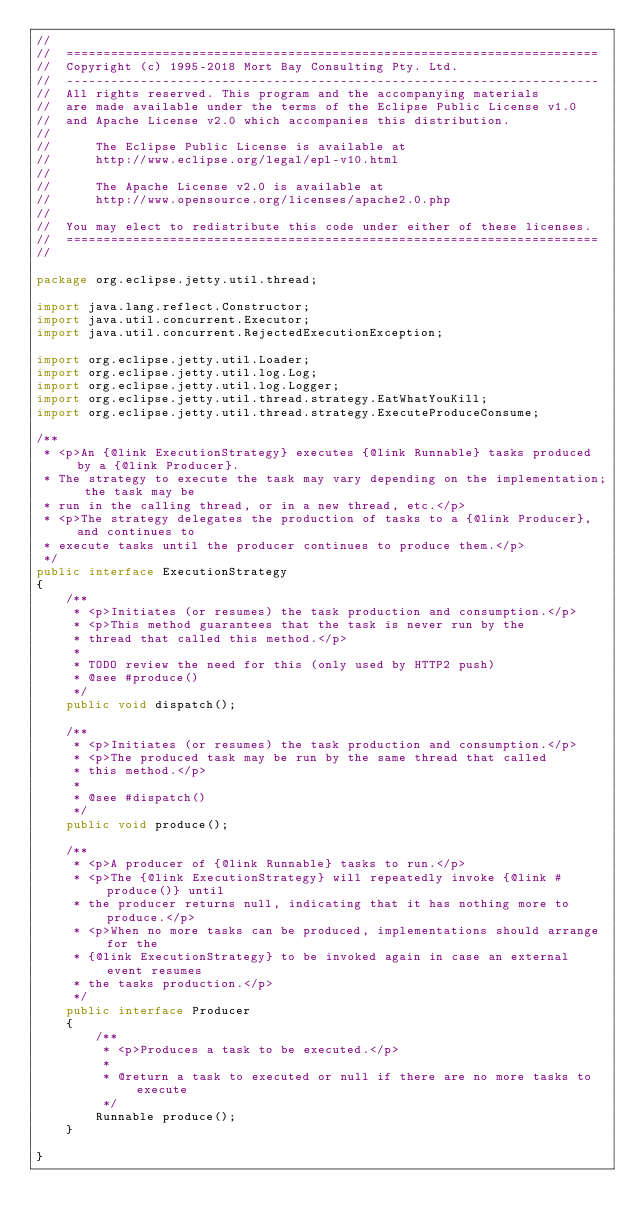<code> <loc_0><loc_0><loc_500><loc_500><_Java_>//
//  ========================================================================
//  Copyright (c) 1995-2018 Mort Bay Consulting Pty. Ltd.
//  ------------------------------------------------------------------------
//  All rights reserved. This program and the accompanying materials
//  are made available under the terms of the Eclipse Public License v1.0
//  and Apache License v2.0 which accompanies this distribution.
//
//      The Eclipse Public License is available at
//      http://www.eclipse.org/legal/epl-v10.html
//
//      The Apache License v2.0 is available at
//      http://www.opensource.org/licenses/apache2.0.php
//
//  You may elect to redistribute this code under either of these licenses.
//  ========================================================================
//

package org.eclipse.jetty.util.thread;

import java.lang.reflect.Constructor;
import java.util.concurrent.Executor;
import java.util.concurrent.RejectedExecutionException;

import org.eclipse.jetty.util.Loader;
import org.eclipse.jetty.util.log.Log;
import org.eclipse.jetty.util.log.Logger;
import org.eclipse.jetty.util.thread.strategy.EatWhatYouKill;
import org.eclipse.jetty.util.thread.strategy.ExecuteProduceConsume;

/**
 * <p>An {@link ExecutionStrategy} executes {@link Runnable} tasks produced by a {@link Producer}.
 * The strategy to execute the task may vary depending on the implementation; the task may be
 * run in the calling thread, or in a new thread, etc.</p>
 * <p>The strategy delegates the production of tasks to a {@link Producer}, and continues to
 * execute tasks until the producer continues to produce them.</p>
 */
public interface ExecutionStrategy
{    
    /**
     * <p>Initiates (or resumes) the task production and consumption.</p>
     * <p>This method guarantees that the task is never run by the
     * thread that called this method.</p>
     *
     * TODO review the need for this (only used by HTTP2 push)
     * @see #produce()
     */
    public void dispatch();

    /**
     * <p>Initiates (or resumes) the task production and consumption.</p>
     * <p>The produced task may be run by the same thread that called
     * this method.</p>
     *
     * @see #dispatch()
     */
    public void produce();
    
    /**
     * <p>A producer of {@link Runnable} tasks to run.</p>
     * <p>The {@link ExecutionStrategy} will repeatedly invoke {@link #produce()} until
     * the producer returns null, indicating that it has nothing more to produce.</p>
     * <p>When no more tasks can be produced, implementations should arrange for the
     * {@link ExecutionStrategy} to be invoked again in case an external event resumes
     * the tasks production.</p>
     */
    public interface Producer
    {
        /**
         * <p>Produces a task to be executed.</p>
         *
         * @return a task to executed or null if there are no more tasks to execute
         */
        Runnable produce();
    }
    
}
</code> 